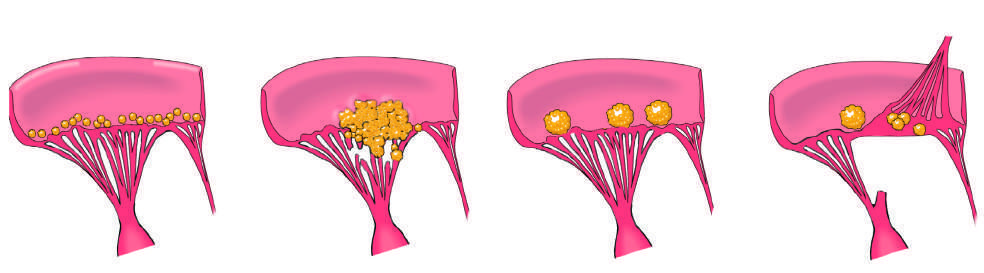what is characterized by small - to medium-sized inflammatory vegetations that can be attached on either side of the valve leaflets?
Answer the question using a single word or phrase. Libman-sacks endocarditis (lse) 